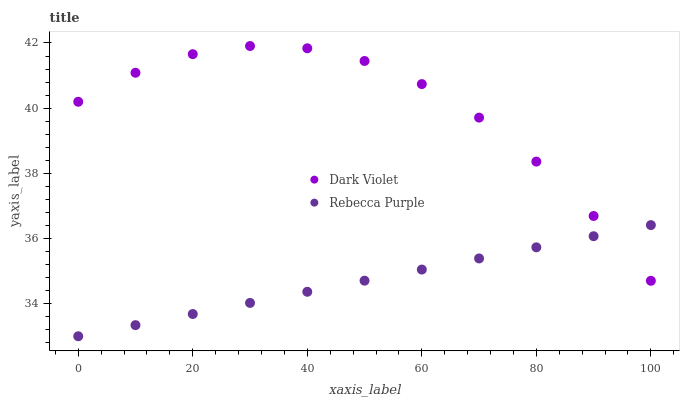Does Rebecca Purple have the minimum area under the curve?
Answer yes or no. Yes. Does Dark Violet have the maximum area under the curve?
Answer yes or no. Yes. Does Dark Violet have the minimum area under the curve?
Answer yes or no. No. Is Rebecca Purple the smoothest?
Answer yes or no. Yes. Is Dark Violet the roughest?
Answer yes or no. Yes. Is Dark Violet the smoothest?
Answer yes or no. No. Does Rebecca Purple have the lowest value?
Answer yes or no. Yes. Does Dark Violet have the lowest value?
Answer yes or no. No. Does Dark Violet have the highest value?
Answer yes or no. Yes. Does Dark Violet intersect Rebecca Purple?
Answer yes or no. Yes. Is Dark Violet less than Rebecca Purple?
Answer yes or no. No. Is Dark Violet greater than Rebecca Purple?
Answer yes or no. No. 